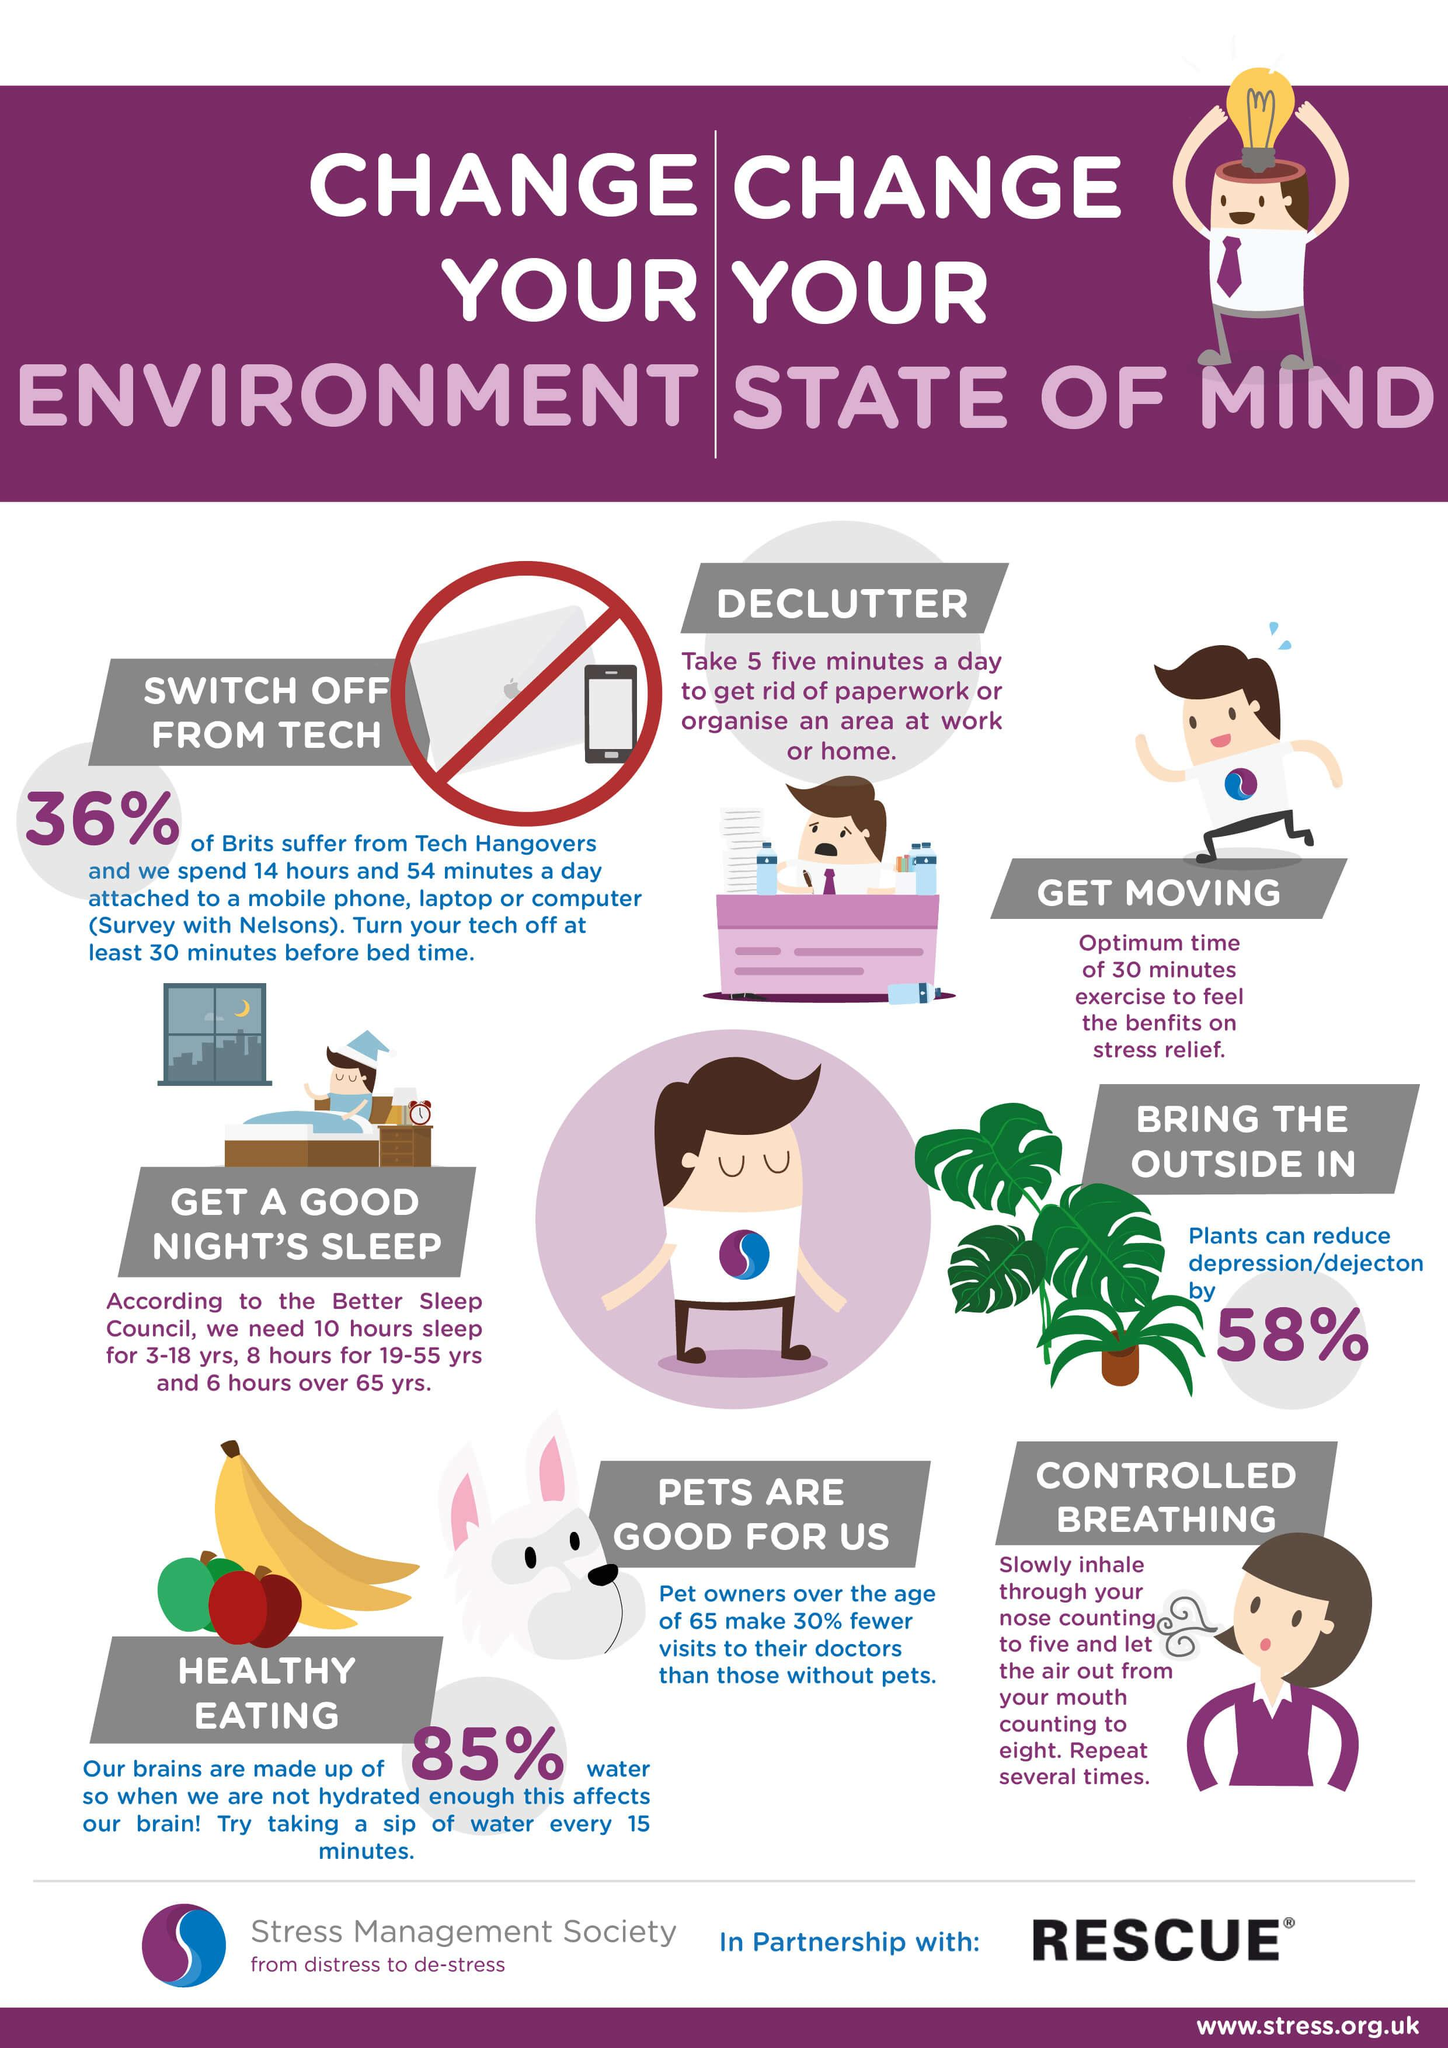Indicate a few pertinent items in this graphic. The cerebrospinal fluid contains 85%. It is imperative to avoid electronic gadgets, breathing exercises, and healthy food before going to sleep to ensure a restful and rejuvenating sleep. 